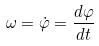<formula> <loc_0><loc_0><loc_500><loc_500>\omega = \dot { \varphi } = \frac { d \varphi } { d t }</formula> 